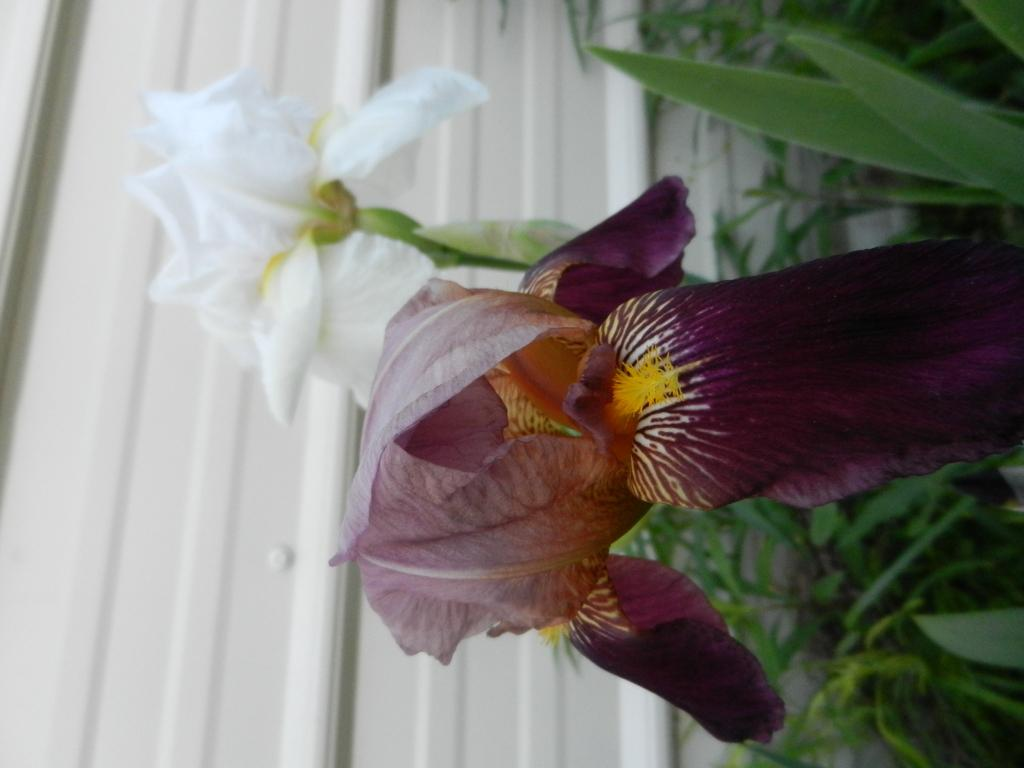What type of plants are present on the right side of the image? There are plants with flowers on the right side of the image. What colors can be seen in the flowers? The flowers are in white and dark purple colors. What is visible in the background of the image? There is a white wall in the background of the image. How many jellyfish are hanging from the flowers in the image? There are no jellyfish present in the image; it features plants with flowers and a white wall in the background. 